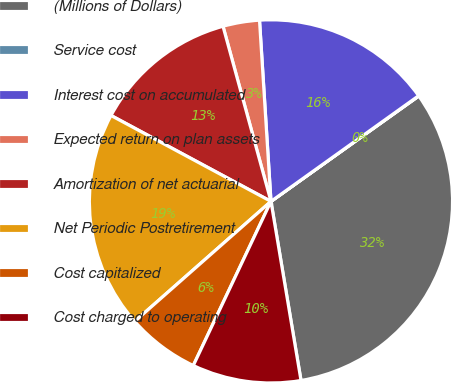Convert chart. <chart><loc_0><loc_0><loc_500><loc_500><pie_chart><fcel>(Millions of Dollars)<fcel>Service cost<fcel>Interest cost on accumulated<fcel>Expected return on plan assets<fcel>Amortization of net actuarial<fcel>Net Periodic Postretirement<fcel>Cost capitalized<fcel>Cost charged to operating<nl><fcel>32.21%<fcel>0.03%<fcel>16.12%<fcel>3.25%<fcel>12.9%<fcel>19.34%<fcel>6.47%<fcel>9.68%<nl></chart> 